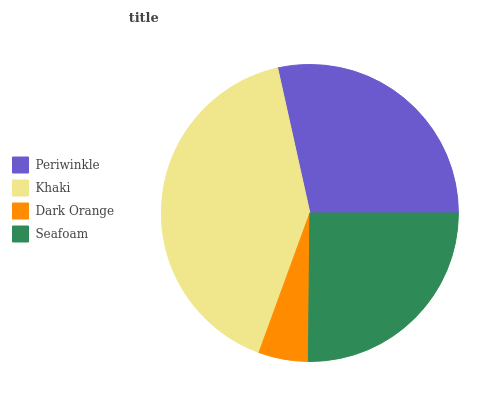Is Dark Orange the minimum?
Answer yes or no. Yes. Is Khaki the maximum?
Answer yes or no. Yes. Is Khaki the minimum?
Answer yes or no. No. Is Dark Orange the maximum?
Answer yes or no. No. Is Khaki greater than Dark Orange?
Answer yes or no. Yes. Is Dark Orange less than Khaki?
Answer yes or no. Yes. Is Dark Orange greater than Khaki?
Answer yes or no. No. Is Khaki less than Dark Orange?
Answer yes or no. No. Is Periwinkle the high median?
Answer yes or no. Yes. Is Seafoam the low median?
Answer yes or no. Yes. Is Khaki the high median?
Answer yes or no. No. Is Periwinkle the low median?
Answer yes or no. No. 